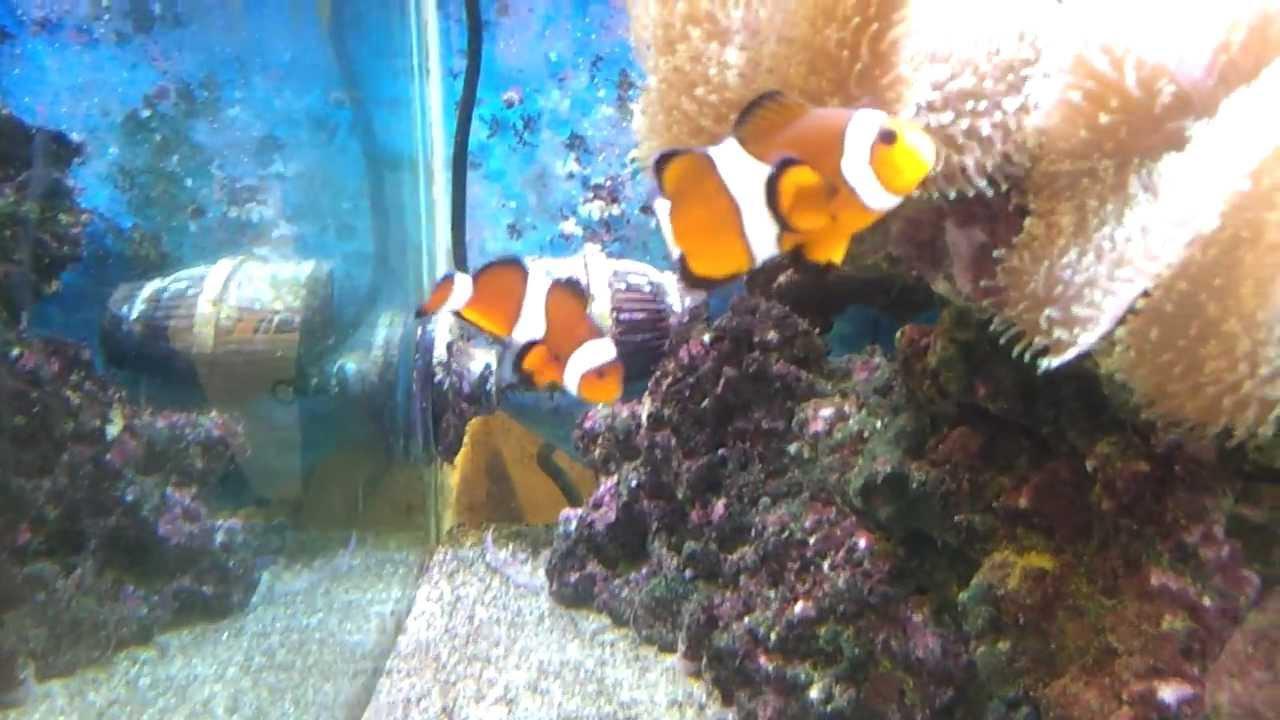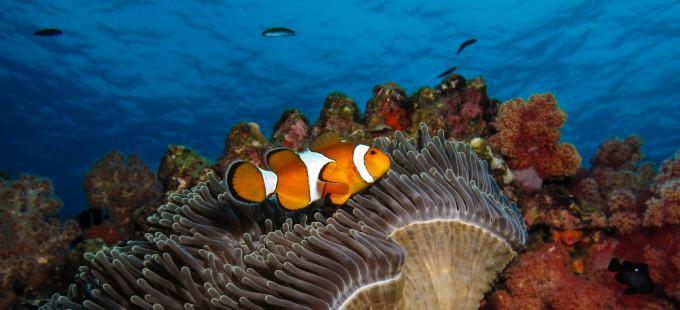The first image is the image on the left, the second image is the image on the right. For the images displayed, is the sentence "An image includes two orange clownfish." factually correct? Answer yes or no. Yes. 